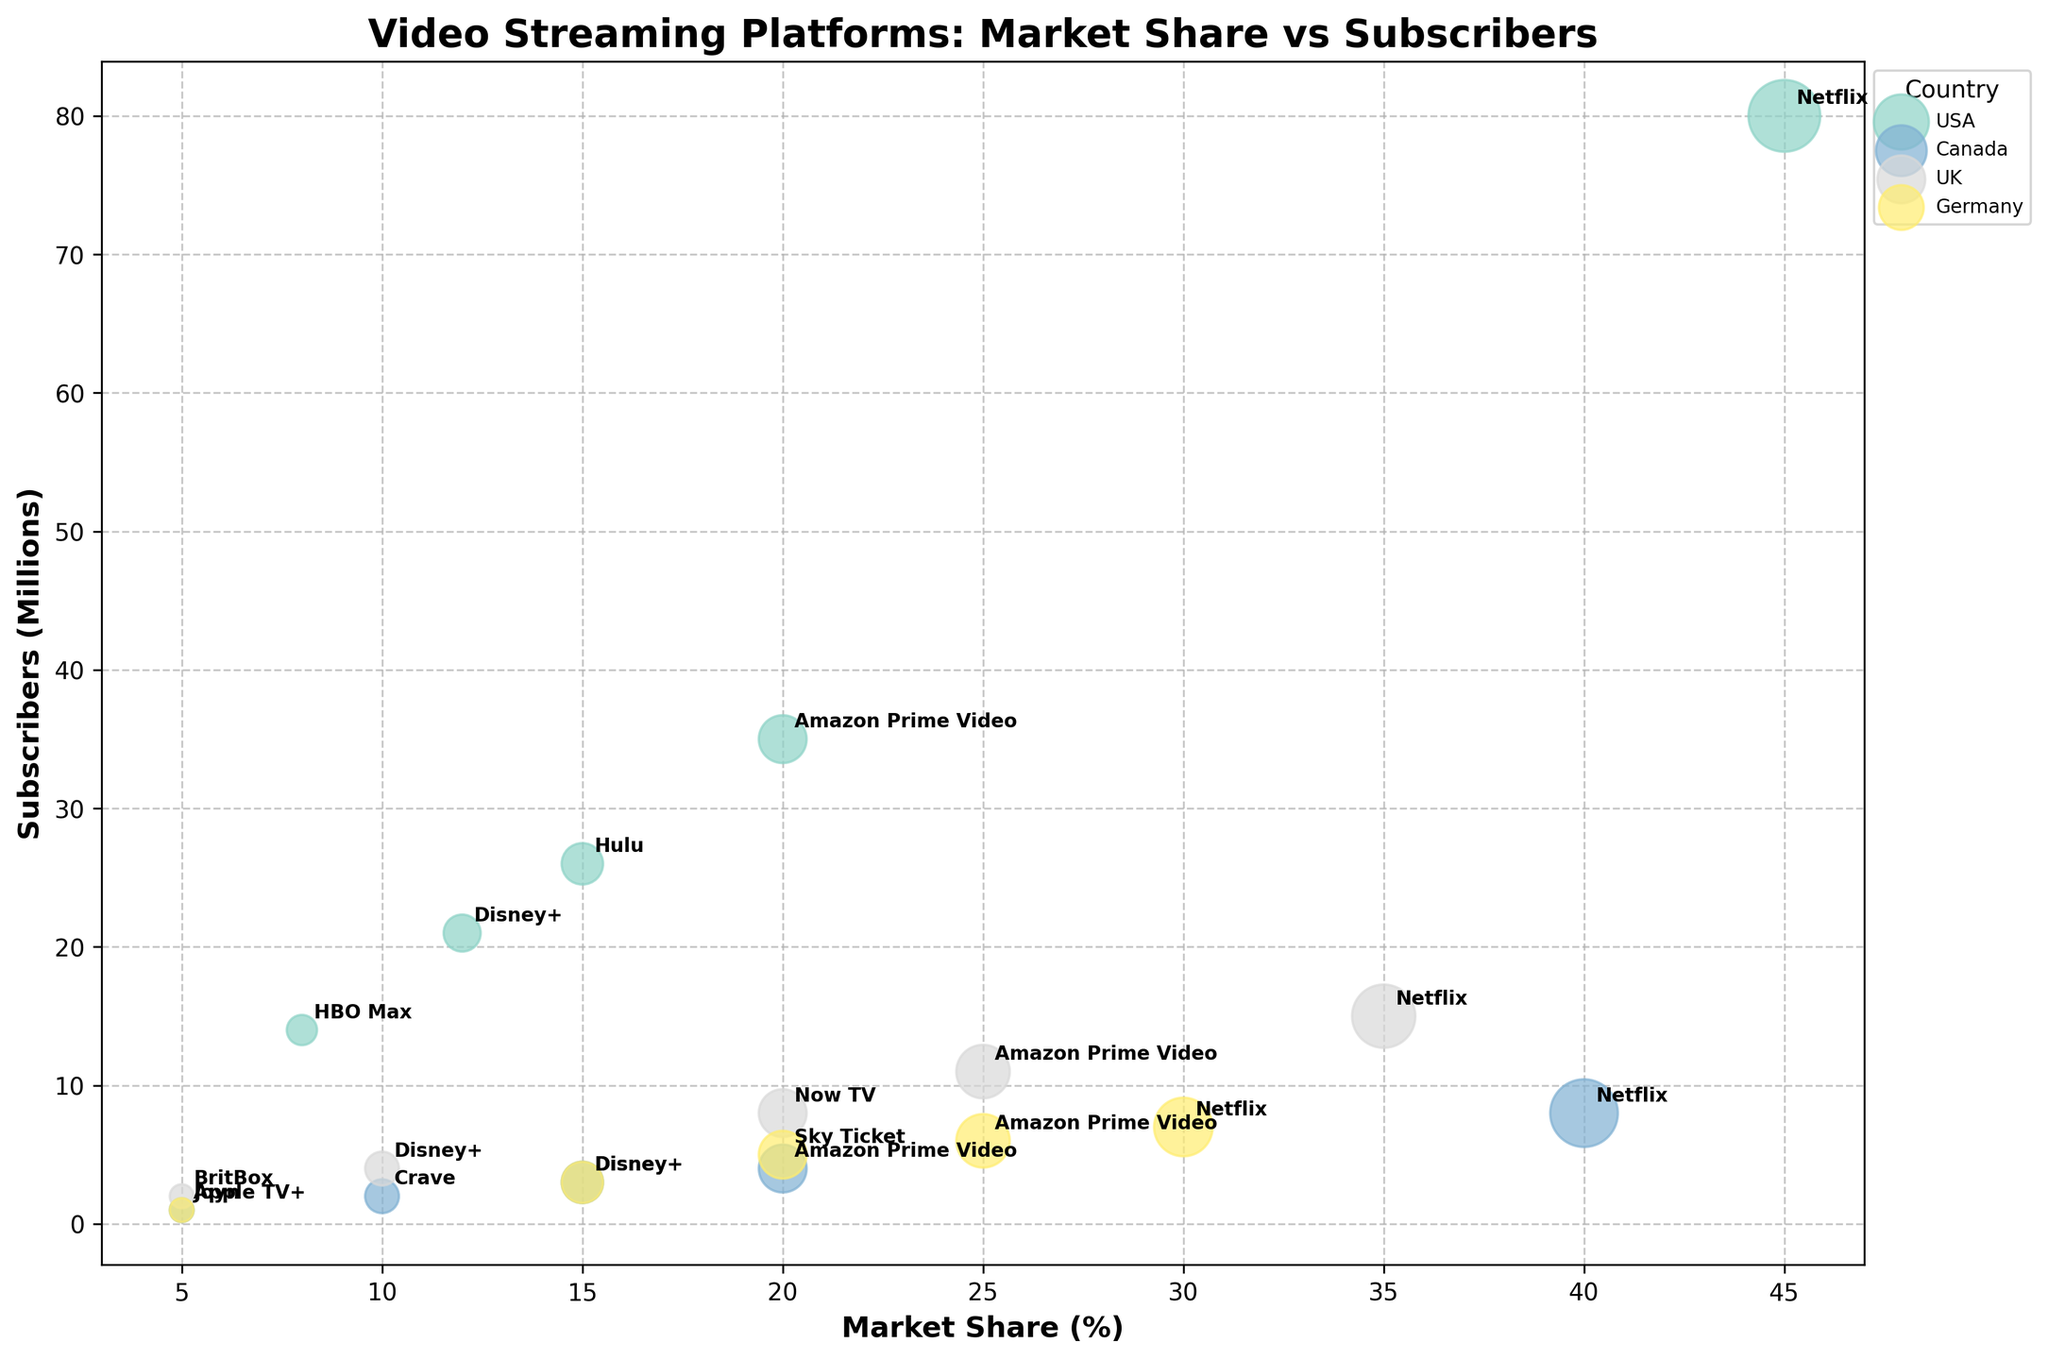What is the title of the chart? The title of the chart is typically displayed at the top of the chart and helps provide an overview of what the chart represents. The title in this chart is "Video Streaming Platforms: Market Share vs Subscribers" as specified in the code.
Answer: Video Streaming Platforms: Market Share vs Subscribers What are the axes labels on the chart? The axes labels provide information on what each axis represents. According to the code, the x-axis is labeled "Market Share (%)" and the y-axis is labeled "Subscribers (Millions)".
Answer: Market Share (%) and Subscribers (Millions) Which country has the most diversified streaming platforms displayed on the chart? To find the most diversified streaming platforms, look for the country with the most unique platforms listed. According to the data, the USA has five platforms listed (Netflix, Hulu, Amazon Prime Video, Disney+, HBO Max).
Answer: USA Which platform has the largest market share in the USA? Look for the largest bubble on the x-axis where it intersects the USA. Based on the data, the largest bubble represents Netflix with a 45% market share.
Answer: Netflix Which platform has the lowest number of subscribers in Germany? To determine this, find the smallest bubble on the y-axis within the Germany group. According to the data, Joyn has only 1 million subscribers.
Answer: Joyn Compare the market share of Netflix in the USA and Canada. Which country has a higher market share for Netflix? Find and compare the value of the bubble size for Netflix in both countries. In the USA, Netflix has a 45% market share, while in Canada, it has a 40% market share.
Answer: USA Which country has the highest total number of subscribers across all platforms? Sum the subscribers for each country individually and compare them. For the USA: 80 + 26 + 35 + 21 + 14 = 176 million. For Canada: 8 + 2 + 4 + 3 + 1 = 18 million. For UK: 15 + 8 + 11 + 4 + 2 = 40 million. For Germany: 7 + 5 + 6 + 3 + 1 = 22 million. The USA has the highest total number of subscribers.
Answer: USA What is the combined market share of all platforms in the UK? Add the market shares of all platforms in the UK. 35% (Netflix) + 20% (Now TV) + 25% (Amazon Prime Video) + 10% (Disney+) + 5% (BritBox) = 95%.
Answer: 95% Which platform has the lowest market share in Canada? Look for the smallest bubble on the x-axis within the Canada group. According to the data, Apple TV+ has a 5% market share.
Answer: Apple TV+ How does the market share of Hulu in the USA compare to the combined market share of non-Netflix platforms in Canada? Find the market share of Hulu (15%) and sum the market shares of all non-Netflix platforms in Canada (10% (Crave) + 20% (Amazon Prime Video) + 15% (Disney+) + 5% (Apple TV+) = 50%). Hulu's market share is less than the combined market share of non-Netflix platforms in Canada.
Answer: Less 